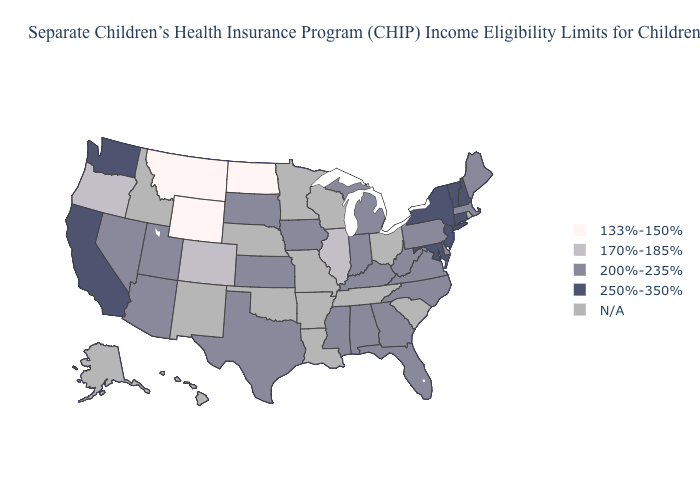Does Alabama have the lowest value in the USA?
Write a very short answer. No. Among the states that border Rhode Island , which have the highest value?
Keep it brief. Connecticut. Does Massachusetts have the lowest value in the Northeast?
Concise answer only. Yes. What is the value of Colorado?
Quick response, please. 170%-185%. What is the value of Idaho?
Give a very brief answer. N/A. Name the states that have a value in the range 200%-235%?
Be succinct. Alabama, Arizona, Delaware, Florida, Georgia, Indiana, Iowa, Kansas, Kentucky, Maine, Massachusetts, Michigan, Mississippi, Nevada, North Carolina, Pennsylvania, South Dakota, Texas, Utah, Virginia, West Virginia. Does the first symbol in the legend represent the smallest category?
Concise answer only. Yes. What is the value of Iowa?
Answer briefly. 200%-235%. Is the legend a continuous bar?
Be succinct. No. Does Maryland have the lowest value in the USA?
Short answer required. No. What is the value of New Hampshire?
Write a very short answer. 250%-350%. Name the states that have a value in the range 200%-235%?
Be succinct. Alabama, Arizona, Delaware, Florida, Georgia, Indiana, Iowa, Kansas, Kentucky, Maine, Massachusetts, Michigan, Mississippi, Nevada, North Carolina, Pennsylvania, South Dakota, Texas, Utah, Virginia, West Virginia. 